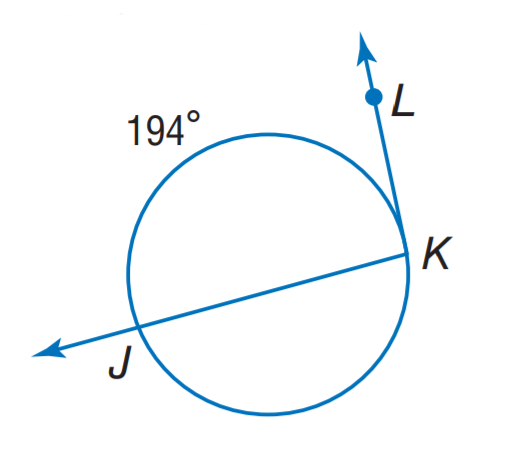Answer the mathemtical geometry problem and directly provide the correct option letter.
Question: Find m \angle K.
Choices: A: 97 B: 112 C: 166 D: 194 A 